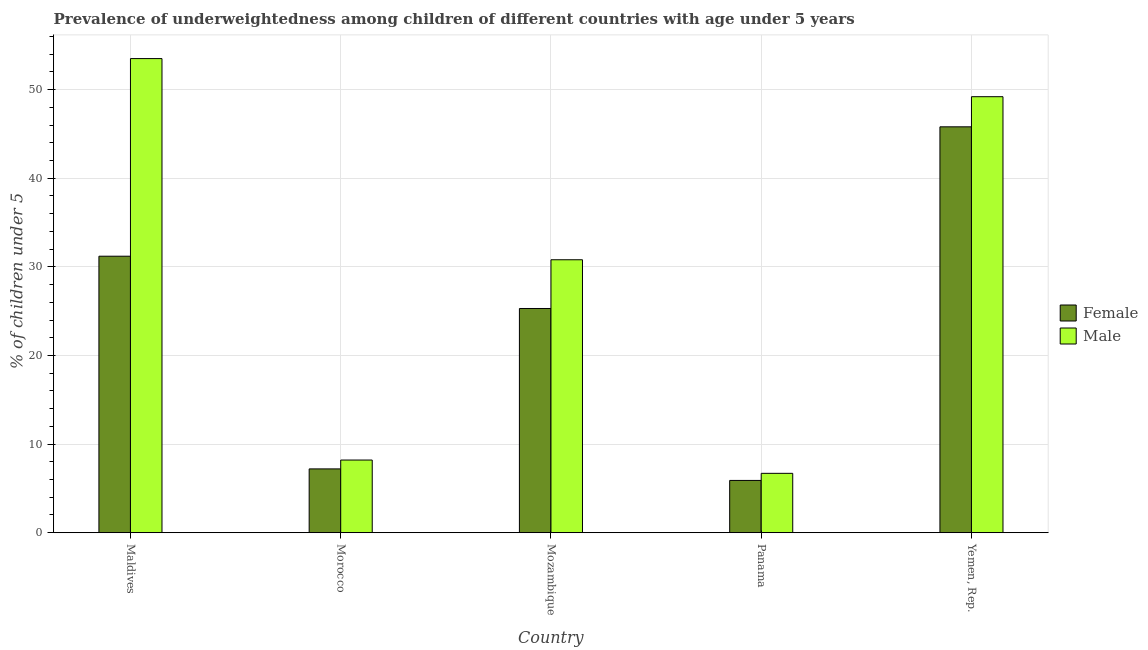Are the number of bars on each tick of the X-axis equal?
Ensure brevity in your answer.  Yes. How many bars are there on the 3rd tick from the left?
Your response must be concise. 2. What is the label of the 2nd group of bars from the left?
Provide a succinct answer. Morocco. In how many cases, is the number of bars for a given country not equal to the number of legend labels?
Ensure brevity in your answer.  0. What is the percentage of underweighted male children in Yemen, Rep.?
Offer a terse response. 49.2. Across all countries, what is the maximum percentage of underweighted male children?
Provide a short and direct response. 53.5. Across all countries, what is the minimum percentage of underweighted female children?
Keep it short and to the point. 5.9. In which country was the percentage of underweighted male children maximum?
Offer a very short reply. Maldives. In which country was the percentage of underweighted male children minimum?
Make the answer very short. Panama. What is the total percentage of underweighted male children in the graph?
Provide a succinct answer. 148.4. What is the difference between the percentage of underweighted male children in Mozambique and that in Panama?
Keep it short and to the point. 24.1. What is the difference between the percentage of underweighted male children in Panama and the percentage of underweighted female children in Mozambique?
Make the answer very short. -18.6. What is the average percentage of underweighted male children per country?
Provide a short and direct response. 29.68. In how many countries, is the percentage of underweighted female children greater than 24 %?
Your answer should be very brief. 3. What is the ratio of the percentage of underweighted female children in Maldives to that in Yemen, Rep.?
Your answer should be compact. 0.68. Is the percentage of underweighted male children in Panama less than that in Yemen, Rep.?
Keep it short and to the point. Yes. Is the difference between the percentage of underweighted female children in Panama and Yemen, Rep. greater than the difference between the percentage of underweighted male children in Panama and Yemen, Rep.?
Your answer should be very brief. Yes. What is the difference between the highest and the second highest percentage of underweighted male children?
Your answer should be very brief. 4.3. What is the difference between the highest and the lowest percentage of underweighted male children?
Give a very brief answer. 46.8. In how many countries, is the percentage of underweighted female children greater than the average percentage of underweighted female children taken over all countries?
Make the answer very short. 3. What does the 2nd bar from the left in Yemen, Rep. represents?
Provide a short and direct response. Male. What does the 2nd bar from the right in Maldives represents?
Offer a terse response. Female. How many bars are there?
Offer a very short reply. 10. Are all the bars in the graph horizontal?
Your answer should be very brief. No. How many countries are there in the graph?
Your answer should be very brief. 5. What is the difference between two consecutive major ticks on the Y-axis?
Your answer should be very brief. 10. Are the values on the major ticks of Y-axis written in scientific E-notation?
Offer a very short reply. No. Does the graph contain any zero values?
Provide a short and direct response. No. How many legend labels are there?
Offer a very short reply. 2. What is the title of the graph?
Your answer should be very brief. Prevalence of underweightedness among children of different countries with age under 5 years. What is the label or title of the X-axis?
Offer a terse response. Country. What is the label or title of the Y-axis?
Offer a terse response.  % of children under 5. What is the  % of children under 5 of Female in Maldives?
Offer a terse response. 31.2. What is the  % of children under 5 of Male in Maldives?
Your response must be concise. 53.5. What is the  % of children under 5 of Female in Morocco?
Offer a terse response. 7.2. What is the  % of children under 5 of Male in Morocco?
Give a very brief answer. 8.2. What is the  % of children under 5 of Female in Mozambique?
Ensure brevity in your answer.  25.3. What is the  % of children under 5 in Male in Mozambique?
Your answer should be very brief. 30.8. What is the  % of children under 5 in Female in Panama?
Your answer should be very brief. 5.9. What is the  % of children under 5 of Male in Panama?
Keep it short and to the point. 6.7. What is the  % of children under 5 of Female in Yemen, Rep.?
Make the answer very short. 45.8. What is the  % of children under 5 in Male in Yemen, Rep.?
Provide a short and direct response. 49.2. Across all countries, what is the maximum  % of children under 5 of Female?
Offer a very short reply. 45.8. Across all countries, what is the maximum  % of children under 5 in Male?
Your response must be concise. 53.5. Across all countries, what is the minimum  % of children under 5 of Female?
Keep it short and to the point. 5.9. Across all countries, what is the minimum  % of children under 5 of Male?
Provide a succinct answer. 6.7. What is the total  % of children under 5 in Female in the graph?
Give a very brief answer. 115.4. What is the total  % of children under 5 in Male in the graph?
Your answer should be compact. 148.4. What is the difference between the  % of children under 5 of Female in Maldives and that in Morocco?
Your response must be concise. 24. What is the difference between the  % of children under 5 of Male in Maldives and that in Morocco?
Provide a short and direct response. 45.3. What is the difference between the  % of children under 5 of Male in Maldives and that in Mozambique?
Your answer should be very brief. 22.7. What is the difference between the  % of children under 5 of Female in Maldives and that in Panama?
Provide a succinct answer. 25.3. What is the difference between the  % of children under 5 of Male in Maldives and that in Panama?
Your answer should be compact. 46.8. What is the difference between the  % of children under 5 of Female in Maldives and that in Yemen, Rep.?
Provide a short and direct response. -14.6. What is the difference between the  % of children under 5 in Male in Maldives and that in Yemen, Rep.?
Give a very brief answer. 4.3. What is the difference between the  % of children under 5 of Female in Morocco and that in Mozambique?
Ensure brevity in your answer.  -18.1. What is the difference between the  % of children under 5 of Male in Morocco and that in Mozambique?
Offer a terse response. -22.6. What is the difference between the  % of children under 5 of Female in Morocco and that in Yemen, Rep.?
Provide a short and direct response. -38.6. What is the difference between the  % of children under 5 in Male in Morocco and that in Yemen, Rep.?
Your answer should be very brief. -41. What is the difference between the  % of children under 5 of Male in Mozambique and that in Panama?
Your response must be concise. 24.1. What is the difference between the  % of children under 5 of Female in Mozambique and that in Yemen, Rep.?
Give a very brief answer. -20.5. What is the difference between the  % of children under 5 of Male in Mozambique and that in Yemen, Rep.?
Your answer should be very brief. -18.4. What is the difference between the  % of children under 5 of Female in Panama and that in Yemen, Rep.?
Your answer should be compact. -39.9. What is the difference between the  % of children under 5 in Male in Panama and that in Yemen, Rep.?
Offer a very short reply. -42.5. What is the difference between the  % of children under 5 in Female in Maldives and the  % of children under 5 in Male in Panama?
Your response must be concise. 24.5. What is the difference between the  % of children under 5 of Female in Morocco and the  % of children under 5 of Male in Mozambique?
Make the answer very short. -23.6. What is the difference between the  % of children under 5 in Female in Morocco and the  % of children under 5 in Male in Yemen, Rep.?
Make the answer very short. -42. What is the difference between the  % of children under 5 in Female in Mozambique and the  % of children under 5 in Male in Yemen, Rep.?
Your response must be concise. -23.9. What is the difference between the  % of children under 5 of Female in Panama and the  % of children under 5 of Male in Yemen, Rep.?
Your answer should be very brief. -43.3. What is the average  % of children under 5 in Female per country?
Your answer should be very brief. 23.08. What is the average  % of children under 5 in Male per country?
Provide a succinct answer. 29.68. What is the difference between the  % of children under 5 of Female and  % of children under 5 of Male in Maldives?
Give a very brief answer. -22.3. What is the difference between the  % of children under 5 in Female and  % of children under 5 in Male in Mozambique?
Your answer should be very brief. -5.5. What is the difference between the  % of children under 5 of Female and  % of children under 5 of Male in Panama?
Make the answer very short. -0.8. What is the difference between the  % of children under 5 of Female and  % of children under 5 of Male in Yemen, Rep.?
Offer a terse response. -3.4. What is the ratio of the  % of children under 5 in Female in Maldives to that in Morocco?
Provide a short and direct response. 4.33. What is the ratio of the  % of children under 5 in Male in Maldives to that in Morocco?
Provide a short and direct response. 6.52. What is the ratio of the  % of children under 5 in Female in Maldives to that in Mozambique?
Offer a very short reply. 1.23. What is the ratio of the  % of children under 5 of Male in Maldives to that in Mozambique?
Give a very brief answer. 1.74. What is the ratio of the  % of children under 5 of Female in Maldives to that in Panama?
Your response must be concise. 5.29. What is the ratio of the  % of children under 5 in Male in Maldives to that in Panama?
Give a very brief answer. 7.99. What is the ratio of the  % of children under 5 in Female in Maldives to that in Yemen, Rep.?
Your answer should be very brief. 0.68. What is the ratio of the  % of children under 5 of Male in Maldives to that in Yemen, Rep.?
Provide a succinct answer. 1.09. What is the ratio of the  % of children under 5 of Female in Morocco to that in Mozambique?
Provide a short and direct response. 0.28. What is the ratio of the  % of children under 5 of Male in Morocco to that in Mozambique?
Offer a terse response. 0.27. What is the ratio of the  % of children under 5 of Female in Morocco to that in Panama?
Keep it short and to the point. 1.22. What is the ratio of the  % of children under 5 of Male in Morocco to that in Panama?
Provide a short and direct response. 1.22. What is the ratio of the  % of children under 5 in Female in Morocco to that in Yemen, Rep.?
Give a very brief answer. 0.16. What is the ratio of the  % of children under 5 of Male in Morocco to that in Yemen, Rep.?
Offer a terse response. 0.17. What is the ratio of the  % of children under 5 in Female in Mozambique to that in Panama?
Provide a short and direct response. 4.29. What is the ratio of the  % of children under 5 in Male in Mozambique to that in Panama?
Provide a short and direct response. 4.6. What is the ratio of the  % of children under 5 of Female in Mozambique to that in Yemen, Rep.?
Keep it short and to the point. 0.55. What is the ratio of the  % of children under 5 of Male in Mozambique to that in Yemen, Rep.?
Offer a terse response. 0.63. What is the ratio of the  % of children under 5 in Female in Panama to that in Yemen, Rep.?
Your answer should be compact. 0.13. What is the ratio of the  % of children under 5 of Male in Panama to that in Yemen, Rep.?
Give a very brief answer. 0.14. What is the difference between the highest and the lowest  % of children under 5 in Female?
Keep it short and to the point. 39.9. What is the difference between the highest and the lowest  % of children under 5 of Male?
Your response must be concise. 46.8. 